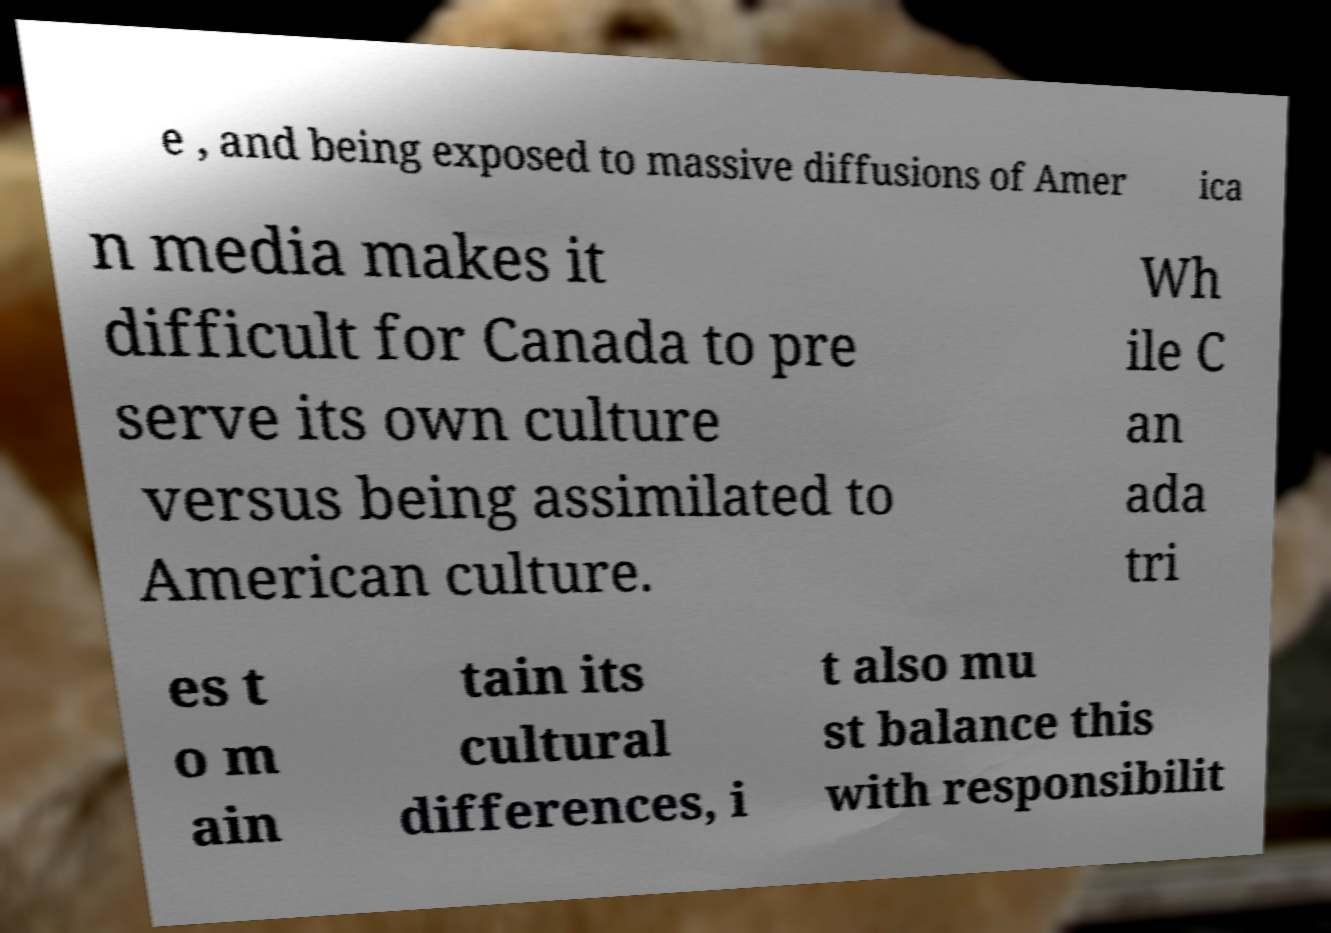Please read and relay the text visible in this image. What does it say? e , and being exposed to massive diffusions of Amer ica n media makes it difficult for Canada to pre serve its own culture versus being assimilated to American culture. Wh ile C an ada tri es t o m ain tain its cultural differences, i t also mu st balance this with responsibilit 